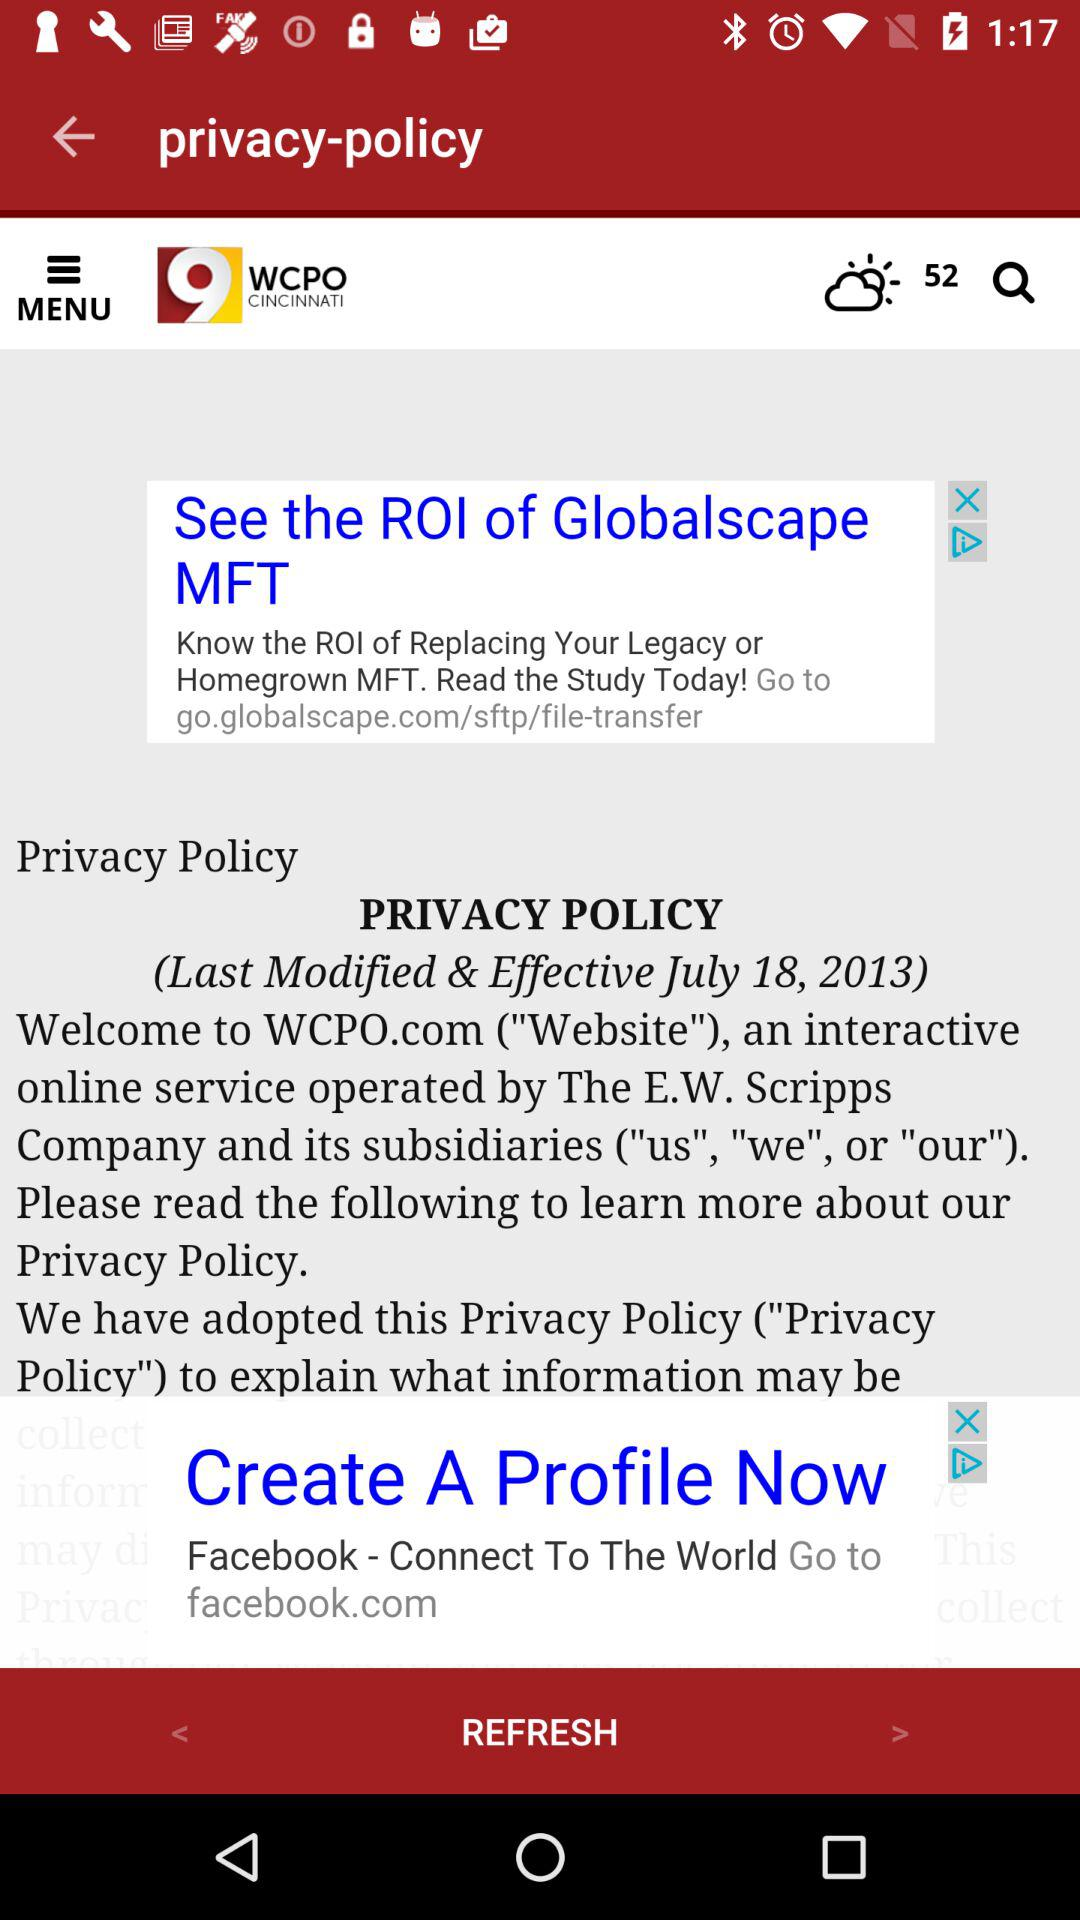What is the app name? The app name is "9 WCPO CINCINNATI". 